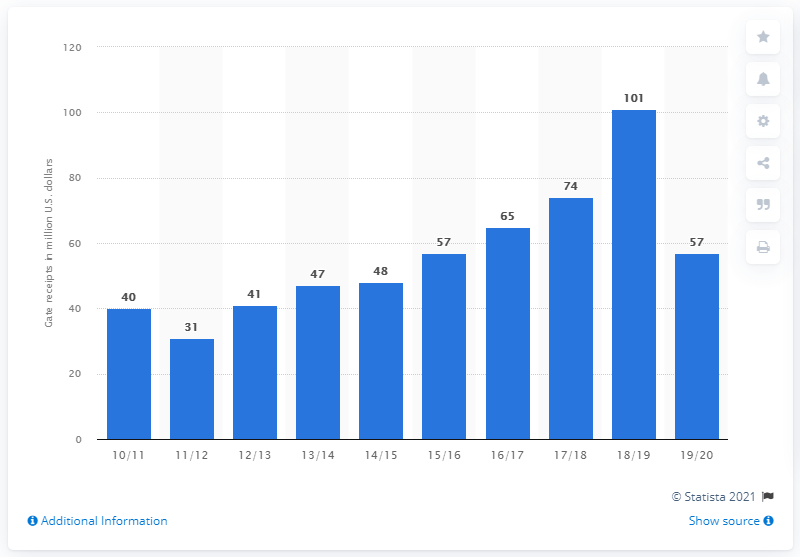Specify some key components in this picture. The gate receipts of the Toronto Raptors in the 2019/20 season were approximately 57 dollars. 